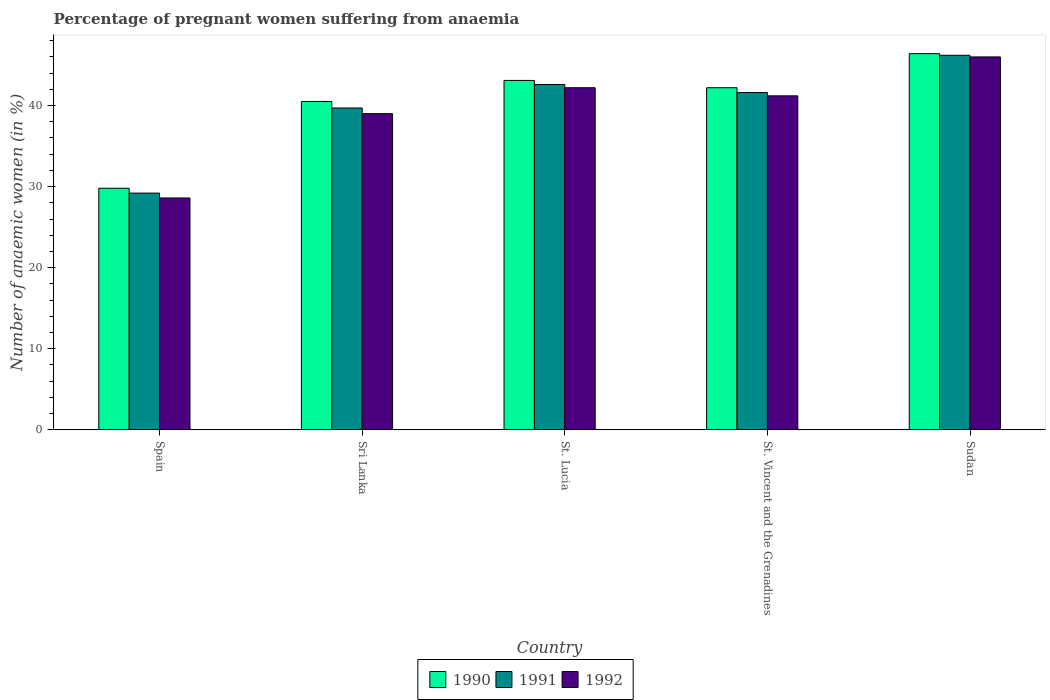Are the number of bars per tick equal to the number of legend labels?
Make the answer very short. Yes. Are the number of bars on each tick of the X-axis equal?
Offer a very short reply. Yes. How many bars are there on the 3rd tick from the left?
Keep it short and to the point. 3. How many bars are there on the 3rd tick from the right?
Give a very brief answer. 3. What is the label of the 4th group of bars from the left?
Your response must be concise. St. Vincent and the Grenadines. What is the number of anaemic women in 1990 in Sri Lanka?
Offer a terse response. 40.5. Across all countries, what is the maximum number of anaemic women in 1990?
Make the answer very short. 46.4. Across all countries, what is the minimum number of anaemic women in 1991?
Your answer should be compact. 29.2. In which country was the number of anaemic women in 1992 maximum?
Your answer should be very brief. Sudan. What is the total number of anaemic women in 1990 in the graph?
Make the answer very short. 202. What is the difference between the number of anaemic women in 1991 in Spain and that in Sri Lanka?
Make the answer very short. -10.5. What is the average number of anaemic women in 1991 per country?
Offer a very short reply. 39.86. What is the difference between the number of anaemic women of/in 1991 and number of anaemic women of/in 1992 in Sudan?
Keep it short and to the point. 0.2. What is the ratio of the number of anaemic women in 1991 in St. Lucia to that in St. Vincent and the Grenadines?
Your answer should be compact. 1.02. Is the number of anaemic women in 1992 in St. Lucia less than that in St. Vincent and the Grenadines?
Your response must be concise. No. Is the difference between the number of anaemic women in 1991 in Spain and St. Lucia greater than the difference between the number of anaemic women in 1992 in Spain and St. Lucia?
Your answer should be compact. Yes. What is the difference between the highest and the lowest number of anaemic women in 1990?
Provide a short and direct response. 16.6. In how many countries, is the number of anaemic women in 1991 greater than the average number of anaemic women in 1991 taken over all countries?
Provide a succinct answer. 3. Is the sum of the number of anaemic women in 1992 in Sri Lanka and St. Lucia greater than the maximum number of anaemic women in 1991 across all countries?
Keep it short and to the point. Yes. What does the 2nd bar from the right in Spain represents?
Offer a terse response. 1991. Is it the case that in every country, the sum of the number of anaemic women in 1991 and number of anaemic women in 1992 is greater than the number of anaemic women in 1990?
Keep it short and to the point. Yes. How many bars are there?
Your response must be concise. 15. Are all the bars in the graph horizontal?
Your answer should be compact. No. Are the values on the major ticks of Y-axis written in scientific E-notation?
Provide a succinct answer. No. How many legend labels are there?
Provide a short and direct response. 3. What is the title of the graph?
Your answer should be compact. Percentage of pregnant women suffering from anaemia. What is the label or title of the X-axis?
Offer a terse response. Country. What is the label or title of the Y-axis?
Provide a short and direct response. Number of anaemic women (in %). What is the Number of anaemic women (in %) in 1990 in Spain?
Offer a terse response. 29.8. What is the Number of anaemic women (in %) in 1991 in Spain?
Ensure brevity in your answer.  29.2. What is the Number of anaemic women (in %) in 1992 in Spain?
Offer a very short reply. 28.6. What is the Number of anaemic women (in %) of 1990 in Sri Lanka?
Give a very brief answer. 40.5. What is the Number of anaemic women (in %) in 1991 in Sri Lanka?
Your answer should be very brief. 39.7. What is the Number of anaemic women (in %) in 1990 in St. Lucia?
Provide a succinct answer. 43.1. What is the Number of anaemic women (in %) in 1991 in St. Lucia?
Ensure brevity in your answer.  42.6. What is the Number of anaemic women (in %) of 1992 in St. Lucia?
Ensure brevity in your answer.  42.2. What is the Number of anaemic women (in %) in 1990 in St. Vincent and the Grenadines?
Offer a very short reply. 42.2. What is the Number of anaemic women (in %) of 1991 in St. Vincent and the Grenadines?
Your answer should be very brief. 41.6. What is the Number of anaemic women (in %) in 1992 in St. Vincent and the Grenadines?
Your answer should be very brief. 41.2. What is the Number of anaemic women (in %) of 1990 in Sudan?
Your answer should be compact. 46.4. What is the Number of anaemic women (in %) of 1991 in Sudan?
Ensure brevity in your answer.  46.2. What is the Number of anaemic women (in %) in 1992 in Sudan?
Offer a terse response. 46. Across all countries, what is the maximum Number of anaemic women (in %) in 1990?
Provide a succinct answer. 46.4. Across all countries, what is the maximum Number of anaemic women (in %) in 1991?
Give a very brief answer. 46.2. Across all countries, what is the minimum Number of anaemic women (in %) in 1990?
Offer a very short reply. 29.8. Across all countries, what is the minimum Number of anaemic women (in %) of 1991?
Give a very brief answer. 29.2. Across all countries, what is the minimum Number of anaemic women (in %) of 1992?
Offer a very short reply. 28.6. What is the total Number of anaemic women (in %) in 1990 in the graph?
Your answer should be very brief. 202. What is the total Number of anaemic women (in %) of 1991 in the graph?
Your answer should be very brief. 199.3. What is the total Number of anaemic women (in %) of 1992 in the graph?
Offer a terse response. 197. What is the difference between the Number of anaemic women (in %) in 1990 in Spain and that in Sri Lanka?
Offer a very short reply. -10.7. What is the difference between the Number of anaemic women (in %) in 1991 in Spain and that in Sri Lanka?
Your response must be concise. -10.5. What is the difference between the Number of anaemic women (in %) in 1992 in Spain and that in St. Lucia?
Offer a very short reply. -13.6. What is the difference between the Number of anaemic women (in %) in 1990 in Spain and that in Sudan?
Make the answer very short. -16.6. What is the difference between the Number of anaemic women (in %) in 1991 in Spain and that in Sudan?
Offer a very short reply. -17. What is the difference between the Number of anaemic women (in %) of 1992 in Spain and that in Sudan?
Give a very brief answer. -17.4. What is the difference between the Number of anaemic women (in %) of 1990 in Sri Lanka and that in St. Lucia?
Keep it short and to the point. -2.6. What is the difference between the Number of anaemic women (in %) of 1992 in Sri Lanka and that in St. Lucia?
Provide a short and direct response. -3.2. What is the difference between the Number of anaemic women (in %) in 1990 in Sri Lanka and that in St. Vincent and the Grenadines?
Your answer should be very brief. -1.7. What is the difference between the Number of anaemic women (in %) in 1992 in Sri Lanka and that in St. Vincent and the Grenadines?
Provide a short and direct response. -2.2. What is the difference between the Number of anaemic women (in %) of 1990 in Sri Lanka and that in Sudan?
Offer a terse response. -5.9. What is the difference between the Number of anaemic women (in %) of 1992 in Sri Lanka and that in Sudan?
Offer a terse response. -7. What is the difference between the Number of anaemic women (in %) in 1991 in St. Lucia and that in St. Vincent and the Grenadines?
Keep it short and to the point. 1. What is the difference between the Number of anaemic women (in %) of 1992 in St. Lucia and that in St. Vincent and the Grenadines?
Offer a very short reply. 1. What is the difference between the Number of anaemic women (in %) of 1990 in St. Lucia and that in Sudan?
Offer a terse response. -3.3. What is the difference between the Number of anaemic women (in %) of 1991 in St. Vincent and the Grenadines and that in Sudan?
Provide a short and direct response. -4.6. What is the difference between the Number of anaemic women (in %) of 1991 in Spain and the Number of anaemic women (in %) of 1992 in Sri Lanka?
Your answer should be very brief. -9.8. What is the difference between the Number of anaemic women (in %) of 1990 in Spain and the Number of anaemic women (in %) of 1991 in St. Lucia?
Your answer should be very brief. -12.8. What is the difference between the Number of anaemic women (in %) of 1991 in Spain and the Number of anaemic women (in %) of 1992 in St. Lucia?
Provide a short and direct response. -13. What is the difference between the Number of anaemic women (in %) in 1990 in Spain and the Number of anaemic women (in %) in 1992 in St. Vincent and the Grenadines?
Provide a short and direct response. -11.4. What is the difference between the Number of anaemic women (in %) of 1991 in Spain and the Number of anaemic women (in %) of 1992 in St. Vincent and the Grenadines?
Make the answer very short. -12. What is the difference between the Number of anaemic women (in %) in 1990 in Spain and the Number of anaemic women (in %) in 1991 in Sudan?
Your answer should be very brief. -16.4. What is the difference between the Number of anaemic women (in %) in 1990 in Spain and the Number of anaemic women (in %) in 1992 in Sudan?
Give a very brief answer. -16.2. What is the difference between the Number of anaemic women (in %) of 1991 in Spain and the Number of anaemic women (in %) of 1992 in Sudan?
Keep it short and to the point. -16.8. What is the difference between the Number of anaemic women (in %) in 1990 in Sri Lanka and the Number of anaemic women (in %) in 1991 in St. Lucia?
Provide a short and direct response. -2.1. What is the difference between the Number of anaemic women (in %) of 1990 in Sri Lanka and the Number of anaemic women (in %) of 1992 in St. Lucia?
Your answer should be compact. -1.7. What is the difference between the Number of anaemic women (in %) in 1991 in Sri Lanka and the Number of anaemic women (in %) in 1992 in St. Lucia?
Give a very brief answer. -2.5. What is the difference between the Number of anaemic women (in %) of 1990 in Sri Lanka and the Number of anaemic women (in %) of 1991 in St. Vincent and the Grenadines?
Offer a terse response. -1.1. What is the difference between the Number of anaemic women (in %) of 1991 in Sri Lanka and the Number of anaemic women (in %) of 1992 in St. Vincent and the Grenadines?
Your answer should be very brief. -1.5. What is the difference between the Number of anaemic women (in %) in 1990 in Sri Lanka and the Number of anaemic women (in %) in 1991 in Sudan?
Keep it short and to the point. -5.7. What is the difference between the Number of anaemic women (in %) of 1991 in Sri Lanka and the Number of anaemic women (in %) of 1992 in Sudan?
Offer a very short reply. -6.3. What is the difference between the Number of anaemic women (in %) of 1991 in St. Lucia and the Number of anaemic women (in %) of 1992 in St. Vincent and the Grenadines?
Your answer should be compact. 1.4. What is the difference between the Number of anaemic women (in %) of 1990 in St. Lucia and the Number of anaemic women (in %) of 1992 in Sudan?
Offer a terse response. -2.9. What is the difference between the Number of anaemic women (in %) in 1990 in St. Vincent and the Grenadines and the Number of anaemic women (in %) in 1991 in Sudan?
Provide a short and direct response. -4. What is the difference between the Number of anaemic women (in %) of 1990 in St. Vincent and the Grenadines and the Number of anaemic women (in %) of 1992 in Sudan?
Keep it short and to the point. -3.8. What is the average Number of anaemic women (in %) of 1990 per country?
Give a very brief answer. 40.4. What is the average Number of anaemic women (in %) in 1991 per country?
Your answer should be very brief. 39.86. What is the average Number of anaemic women (in %) in 1992 per country?
Provide a succinct answer. 39.4. What is the difference between the Number of anaemic women (in %) in 1990 and Number of anaemic women (in %) in 1991 in Spain?
Offer a terse response. 0.6. What is the difference between the Number of anaemic women (in %) of 1990 and Number of anaemic women (in %) of 1991 in Sri Lanka?
Make the answer very short. 0.8. What is the difference between the Number of anaemic women (in %) of 1990 and Number of anaemic women (in %) of 1992 in Sri Lanka?
Your answer should be compact. 1.5. What is the difference between the Number of anaemic women (in %) of 1991 and Number of anaemic women (in %) of 1992 in St. Vincent and the Grenadines?
Offer a very short reply. 0.4. What is the difference between the Number of anaemic women (in %) of 1990 and Number of anaemic women (in %) of 1992 in Sudan?
Offer a very short reply. 0.4. What is the difference between the Number of anaemic women (in %) in 1991 and Number of anaemic women (in %) in 1992 in Sudan?
Your answer should be very brief. 0.2. What is the ratio of the Number of anaemic women (in %) in 1990 in Spain to that in Sri Lanka?
Ensure brevity in your answer.  0.74. What is the ratio of the Number of anaemic women (in %) of 1991 in Spain to that in Sri Lanka?
Your answer should be compact. 0.74. What is the ratio of the Number of anaemic women (in %) of 1992 in Spain to that in Sri Lanka?
Make the answer very short. 0.73. What is the ratio of the Number of anaemic women (in %) in 1990 in Spain to that in St. Lucia?
Your answer should be very brief. 0.69. What is the ratio of the Number of anaemic women (in %) of 1991 in Spain to that in St. Lucia?
Give a very brief answer. 0.69. What is the ratio of the Number of anaemic women (in %) of 1992 in Spain to that in St. Lucia?
Your response must be concise. 0.68. What is the ratio of the Number of anaemic women (in %) of 1990 in Spain to that in St. Vincent and the Grenadines?
Provide a succinct answer. 0.71. What is the ratio of the Number of anaemic women (in %) in 1991 in Spain to that in St. Vincent and the Grenadines?
Provide a short and direct response. 0.7. What is the ratio of the Number of anaemic women (in %) in 1992 in Spain to that in St. Vincent and the Grenadines?
Ensure brevity in your answer.  0.69. What is the ratio of the Number of anaemic women (in %) of 1990 in Spain to that in Sudan?
Provide a short and direct response. 0.64. What is the ratio of the Number of anaemic women (in %) in 1991 in Spain to that in Sudan?
Provide a short and direct response. 0.63. What is the ratio of the Number of anaemic women (in %) of 1992 in Spain to that in Sudan?
Provide a short and direct response. 0.62. What is the ratio of the Number of anaemic women (in %) of 1990 in Sri Lanka to that in St. Lucia?
Keep it short and to the point. 0.94. What is the ratio of the Number of anaemic women (in %) of 1991 in Sri Lanka to that in St. Lucia?
Your answer should be compact. 0.93. What is the ratio of the Number of anaemic women (in %) in 1992 in Sri Lanka to that in St. Lucia?
Ensure brevity in your answer.  0.92. What is the ratio of the Number of anaemic women (in %) of 1990 in Sri Lanka to that in St. Vincent and the Grenadines?
Ensure brevity in your answer.  0.96. What is the ratio of the Number of anaemic women (in %) of 1991 in Sri Lanka to that in St. Vincent and the Grenadines?
Your answer should be compact. 0.95. What is the ratio of the Number of anaemic women (in %) of 1992 in Sri Lanka to that in St. Vincent and the Grenadines?
Make the answer very short. 0.95. What is the ratio of the Number of anaemic women (in %) of 1990 in Sri Lanka to that in Sudan?
Your answer should be very brief. 0.87. What is the ratio of the Number of anaemic women (in %) in 1991 in Sri Lanka to that in Sudan?
Offer a very short reply. 0.86. What is the ratio of the Number of anaemic women (in %) of 1992 in Sri Lanka to that in Sudan?
Offer a terse response. 0.85. What is the ratio of the Number of anaemic women (in %) in 1990 in St. Lucia to that in St. Vincent and the Grenadines?
Offer a terse response. 1.02. What is the ratio of the Number of anaemic women (in %) in 1992 in St. Lucia to that in St. Vincent and the Grenadines?
Provide a short and direct response. 1.02. What is the ratio of the Number of anaemic women (in %) of 1990 in St. Lucia to that in Sudan?
Your answer should be very brief. 0.93. What is the ratio of the Number of anaemic women (in %) in 1991 in St. Lucia to that in Sudan?
Ensure brevity in your answer.  0.92. What is the ratio of the Number of anaemic women (in %) of 1992 in St. Lucia to that in Sudan?
Your answer should be very brief. 0.92. What is the ratio of the Number of anaemic women (in %) in 1990 in St. Vincent and the Grenadines to that in Sudan?
Keep it short and to the point. 0.91. What is the ratio of the Number of anaemic women (in %) in 1991 in St. Vincent and the Grenadines to that in Sudan?
Your answer should be compact. 0.9. What is the ratio of the Number of anaemic women (in %) in 1992 in St. Vincent and the Grenadines to that in Sudan?
Offer a terse response. 0.9. What is the difference between the highest and the second highest Number of anaemic women (in %) of 1990?
Ensure brevity in your answer.  3.3. What is the difference between the highest and the lowest Number of anaemic women (in %) in 1992?
Your answer should be very brief. 17.4. 